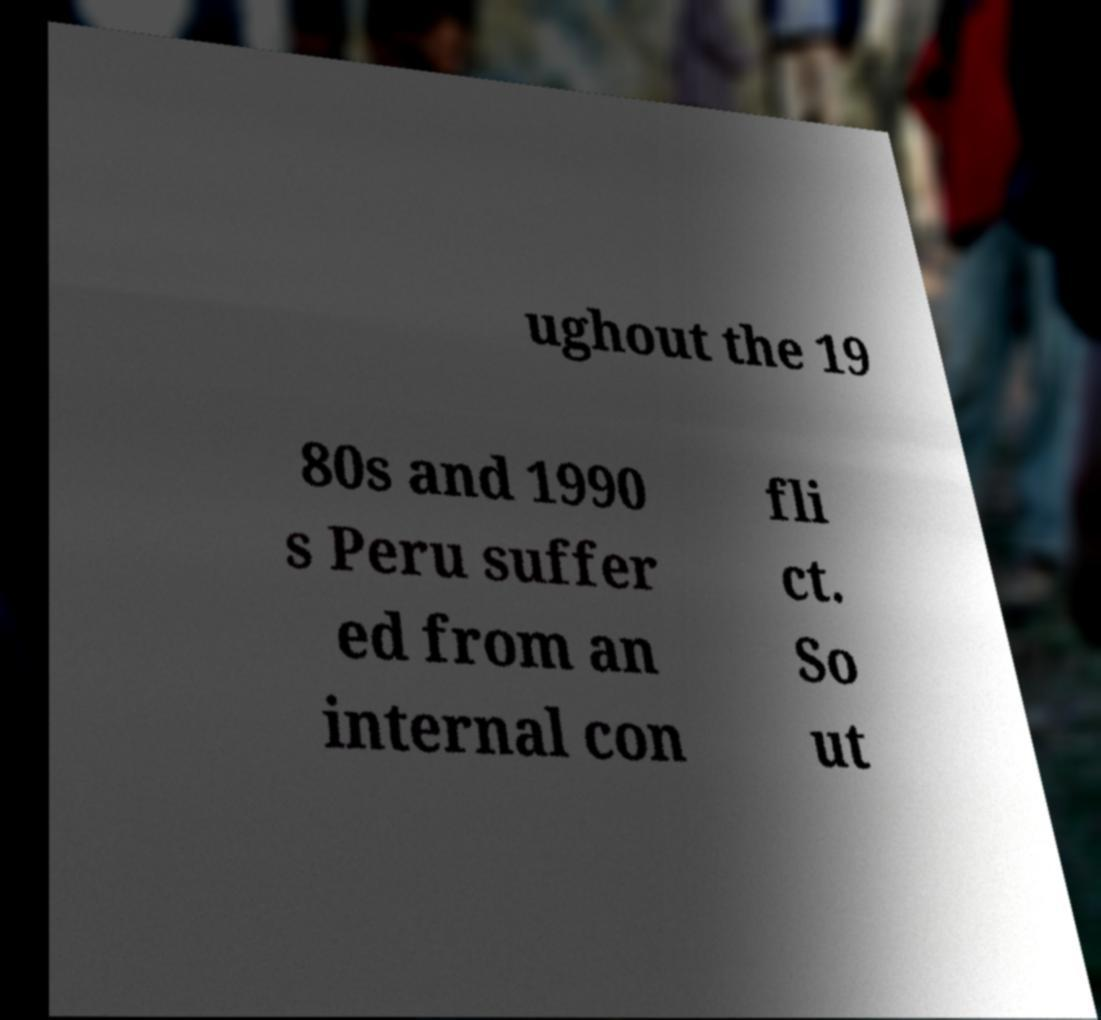For documentation purposes, I need the text within this image transcribed. Could you provide that? ughout the 19 80s and 1990 s Peru suffer ed from an internal con fli ct. So ut 